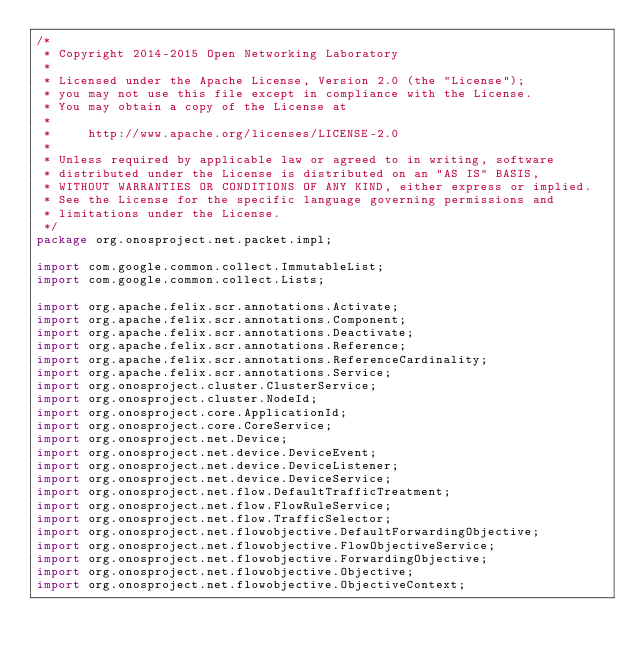Convert code to text. <code><loc_0><loc_0><loc_500><loc_500><_Java_>/*
 * Copyright 2014-2015 Open Networking Laboratory
 *
 * Licensed under the Apache License, Version 2.0 (the "License");
 * you may not use this file except in compliance with the License.
 * You may obtain a copy of the License at
 *
 *     http://www.apache.org/licenses/LICENSE-2.0
 *
 * Unless required by applicable law or agreed to in writing, software
 * distributed under the License is distributed on an "AS IS" BASIS,
 * WITHOUT WARRANTIES OR CONDITIONS OF ANY KIND, either express or implied.
 * See the License for the specific language governing permissions and
 * limitations under the License.
 */
package org.onosproject.net.packet.impl;

import com.google.common.collect.ImmutableList;
import com.google.common.collect.Lists;

import org.apache.felix.scr.annotations.Activate;
import org.apache.felix.scr.annotations.Component;
import org.apache.felix.scr.annotations.Deactivate;
import org.apache.felix.scr.annotations.Reference;
import org.apache.felix.scr.annotations.ReferenceCardinality;
import org.apache.felix.scr.annotations.Service;
import org.onosproject.cluster.ClusterService;
import org.onosproject.cluster.NodeId;
import org.onosproject.core.ApplicationId;
import org.onosproject.core.CoreService;
import org.onosproject.net.Device;
import org.onosproject.net.device.DeviceEvent;
import org.onosproject.net.device.DeviceListener;
import org.onosproject.net.device.DeviceService;
import org.onosproject.net.flow.DefaultTrafficTreatment;
import org.onosproject.net.flow.FlowRuleService;
import org.onosproject.net.flow.TrafficSelector;
import org.onosproject.net.flowobjective.DefaultForwardingObjective;
import org.onosproject.net.flowobjective.FlowObjectiveService;
import org.onosproject.net.flowobjective.ForwardingObjective;
import org.onosproject.net.flowobjective.Objective;
import org.onosproject.net.flowobjective.ObjectiveContext;</code> 